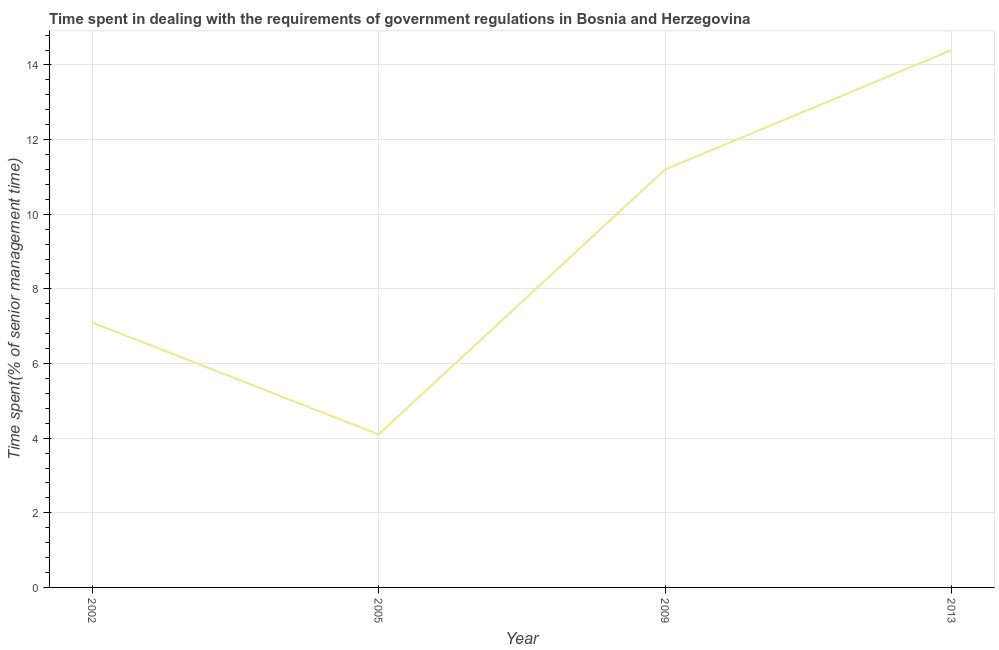What is the time spent in dealing with government regulations in 2005?
Give a very brief answer. 4.1. Across all years, what is the maximum time spent in dealing with government regulations?
Provide a short and direct response. 14.4. Across all years, what is the minimum time spent in dealing with government regulations?
Your answer should be compact. 4.1. What is the sum of the time spent in dealing with government regulations?
Make the answer very short. 36.8. What is the difference between the time spent in dealing with government regulations in 2002 and 2013?
Your answer should be very brief. -7.3. What is the average time spent in dealing with government regulations per year?
Provide a short and direct response. 9.2. What is the median time spent in dealing with government regulations?
Keep it short and to the point. 9.15. In how many years, is the time spent in dealing with government regulations greater than 10.4 %?
Make the answer very short. 2. What is the ratio of the time spent in dealing with government regulations in 2005 to that in 2009?
Provide a short and direct response. 0.37. Is the time spent in dealing with government regulations in 2005 less than that in 2009?
Your answer should be very brief. Yes. What is the difference between the highest and the second highest time spent in dealing with government regulations?
Offer a very short reply. 3.2. Is the sum of the time spent in dealing with government regulations in 2009 and 2013 greater than the maximum time spent in dealing with government regulations across all years?
Offer a terse response. Yes. What is the difference between the highest and the lowest time spent in dealing with government regulations?
Provide a succinct answer. 10.3. In how many years, is the time spent in dealing with government regulations greater than the average time spent in dealing with government regulations taken over all years?
Provide a short and direct response. 2. How many years are there in the graph?
Offer a terse response. 4. What is the title of the graph?
Your answer should be compact. Time spent in dealing with the requirements of government regulations in Bosnia and Herzegovina. What is the label or title of the X-axis?
Your answer should be very brief. Year. What is the label or title of the Y-axis?
Provide a short and direct response. Time spent(% of senior management time). What is the Time spent(% of senior management time) of 2005?
Keep it short and to the point. 4.1. What is the Time spent(% of senior management time) in 2009?
Your answer should be very brief. 11.2. What is the Time spent(% of senior management time) in 2013?
Offer a terse response. 14.4. What is the difference between the Time spent(% of senior management time) in 2002 and 2005?
Make the answer very short. 3. What is the difference between the Time spent(% of senior management time) in 2002 and 2013?
Your response must be concise. -7.3. What is the ratio of the Time spent(% of senior management time) in 2002 to that in 2005?
Offer a terse response. 1.73. What is the ratio of the Time spent(% of senior management time) in 2002 to that in 2009?
Provide a short and direct response. 0.63. What is the ratio of the Time spent(% of senior management time) in 2002 to that in 2013?
Offer a very short reply. 0.49. What is the ratio of the Time spent(% of senior management time) in 2005 to that in 2009?
Make the answer very short. 0.37. What is the ratio of the Time spent(% of senior management time) in 2005 to that in 2013?
Your answer should be very brief. 0.28. What is the ratio of the Time spent(% of senior management time) in 2009 to that in 2013?
Keep it short and to the point. 0.78. 